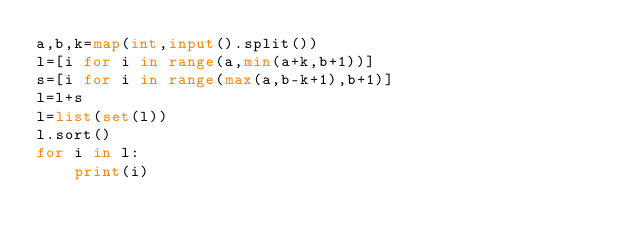Convert code to text. <code><loc_0><loc_0><loc_500><loc_500><_Python_>a,b,k=map(int,input().split())
l=[i for i in range(a,min(a+k,b+1))]
s=[i for i in range(max(a,b-k+1),b+1)]
l=l+s
l=list(set(l))
l.sort()
for i in l:
    print(i)</code> 